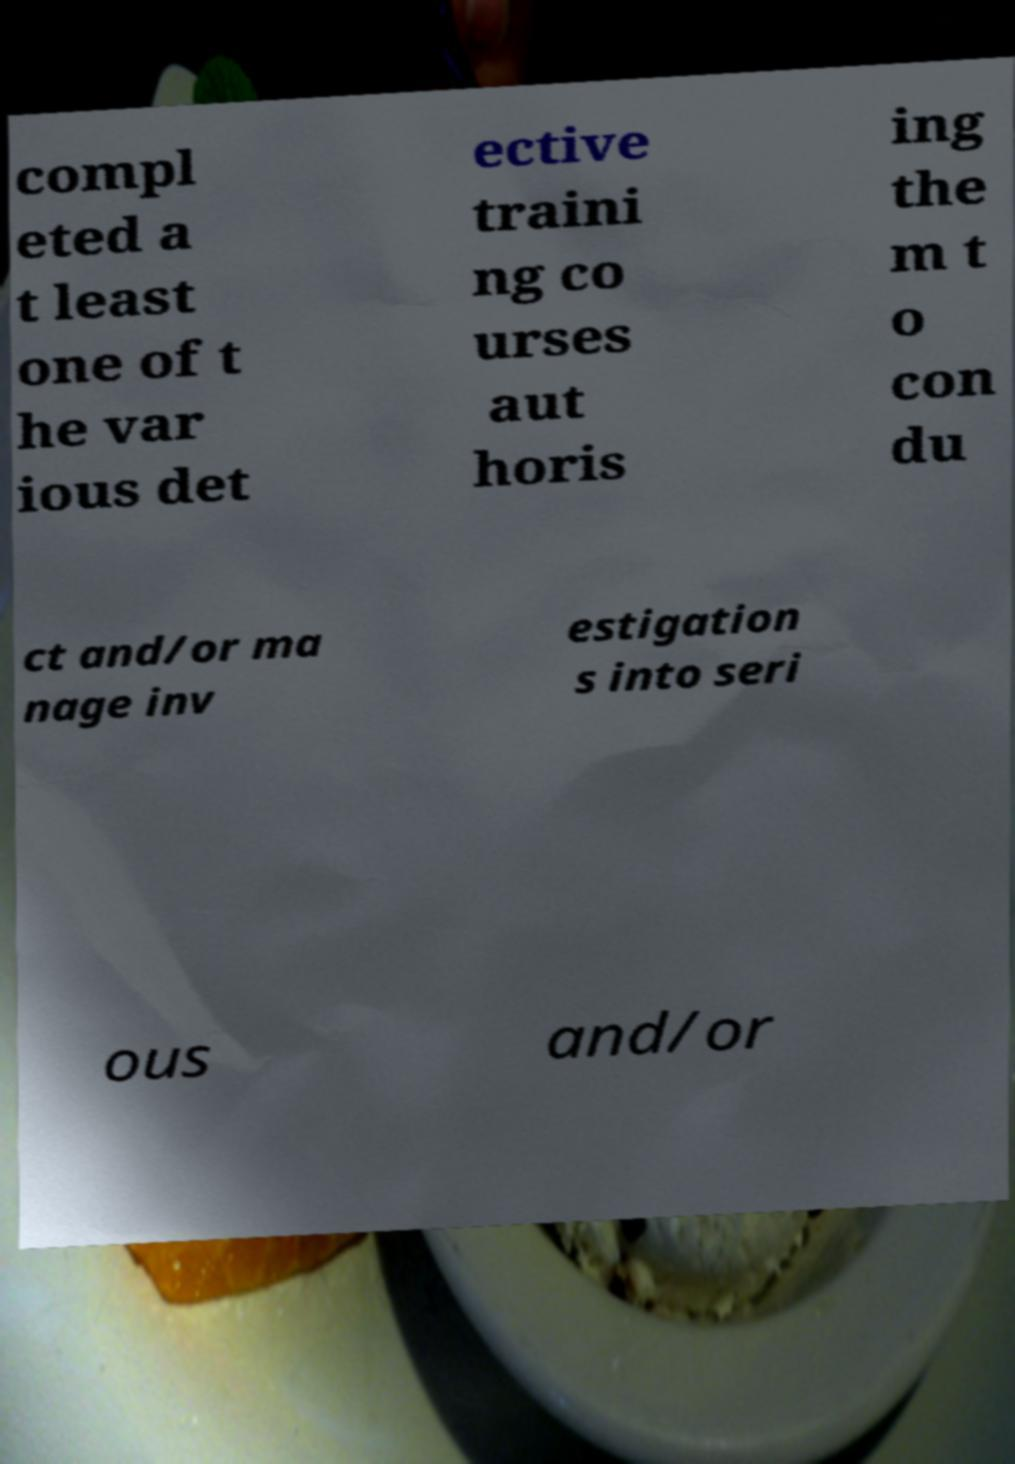Could you extract and type out the text from this image? compl eted a t least one of t he var ious det ective traini ng co urses aut horis ing the m t o con du ct and/or ma nage inv estigation s into seri ous and/or 